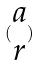Convert formula to latex. <formula><loc_0><loc_0><loc_500><loc_500>( \begin{matrix} a \\ r \end{matrix} )</formula> 